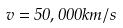Convert formula to latex. <formula><loc_0><loc_0><loc_500><loc_500>v = 5 0 , 0 0 0 k m / s</formula> 